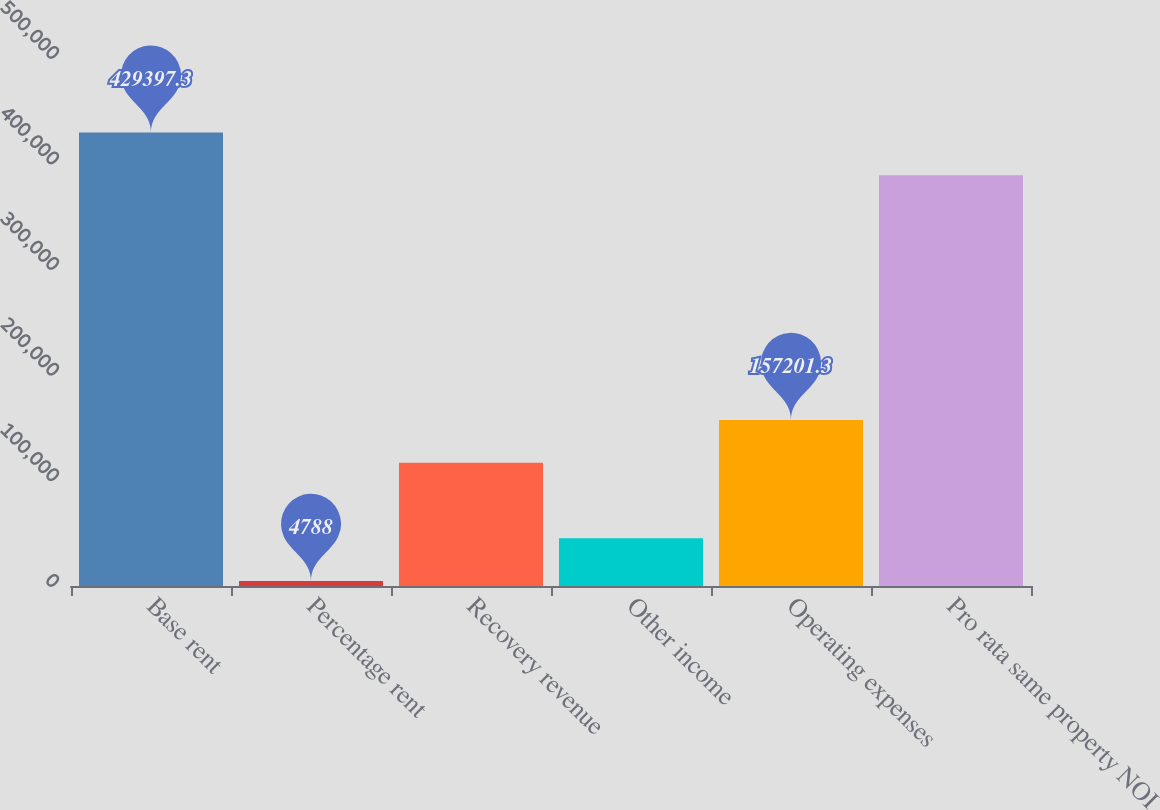Convert chart to OTSL. <chart><loc_0><loc_0><loc_500><loc_500><bar_chart><fcel>Base rent<fcel>Percentage rent<fcel>Recovery revenue<fcel>Other income<fcel>Operating expenses<fcel>Pro rata same property NOI<nl><fcel>429397<fcel>4788<fcel>116716<fcel>45273.3<fcel>157201<fcel>388912<nl></chart> 